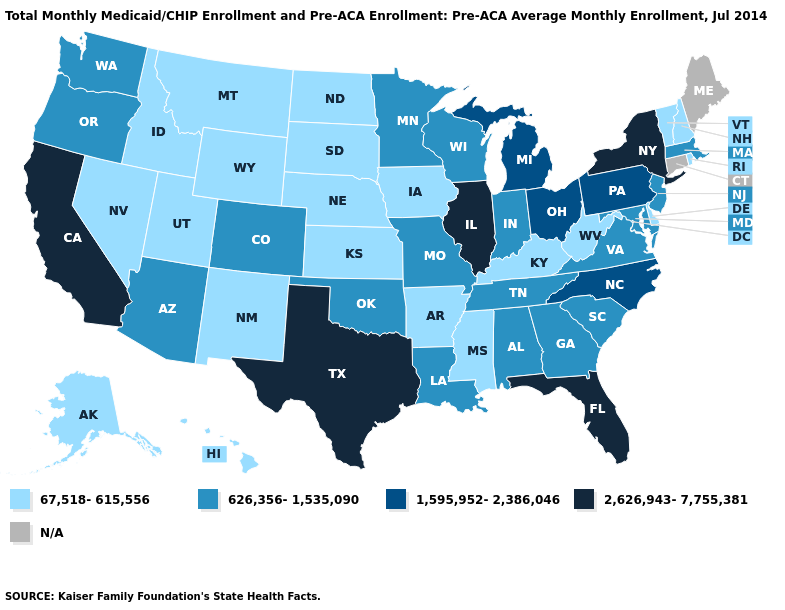Does Illinois have the highest value in the MidWest?
Short answer required. Yes. What is the value of Missouri?
Answer briefly. 626,356-1,535,090. Does Pennsylvania have the highest value in the USA?
Concise answer only. No. What is the value of New Hampshire?
Concise answer only. 67,518-615,556. Name the states that have a value in the range 67,518-615,556?
Be succinct. Alaska, Arkansas, Delaware, Hawaii, Idaho, Iowa, Kansas, Kentucky, Mississippi, Montana, Nebraska, Nevada, New Hampshire, New Mexico, North Dakota, Rhode Island, South Dakota, Utah, Vermont, West Virginia, Wyoming. What is the value of Nevada?
Write a very short answer. 67,518-615,556. What is the value of Virginia?
Give a very brief answer. 626,356-1,535,090. What is the lowest value in the USA?
Be succinct. 67,518-615,556. Does California have the highest value in the USA?
Answer briefly. Yes. Does Vermont have the lowest value in the Northeast?
Quick response, please. Yes. Does the map have missing data?
Answer briefly. Yes. Among the states that border Nevada , which have the lowest value?
Answer briefly. Idaho, Utah. What is the value of Vermont?
Give a very brief answer. 67,518-615,556. What is the highest value in the USA?
Concise answer only. 2,626,943-7,755,381. What is the value of New Mexico?
Concise answer only. 67,518-615,556. 